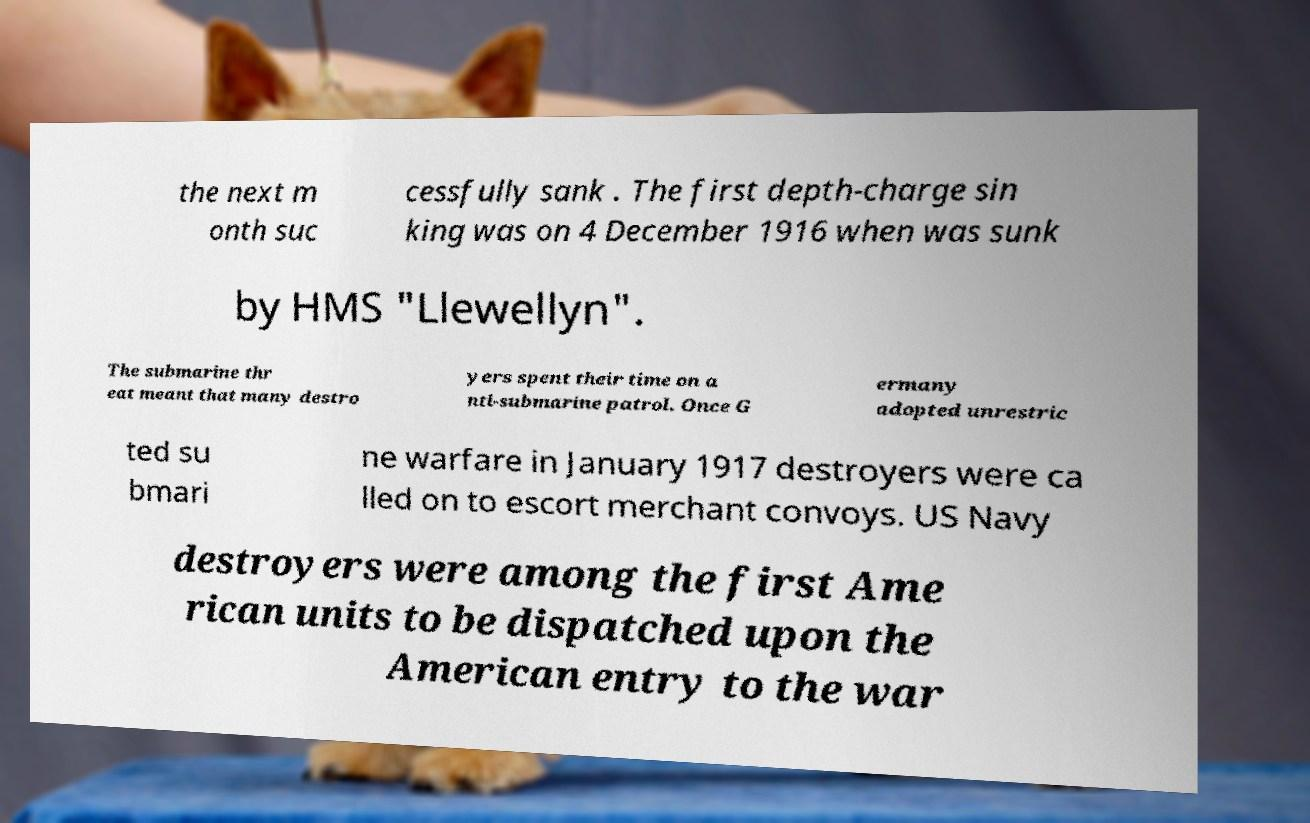What messages or text are displayed in this image? I need them in a readable, typed format. the next m onth suc cessfully sank . The first depth-charge sin king was on 4 December 1916 when was sunk by HMS "Llewellyn". The submarine thr eat meant that many destro yers spent their time on a nti-submarine patrol. Once G ermany adopted unrestric ted su bmari ne warfare in January 1917 destroyers were ca lled on to escort merchant convoys. US Navy destroyers were among the first Ame rican units to be dispatched upon the American entry to the war 